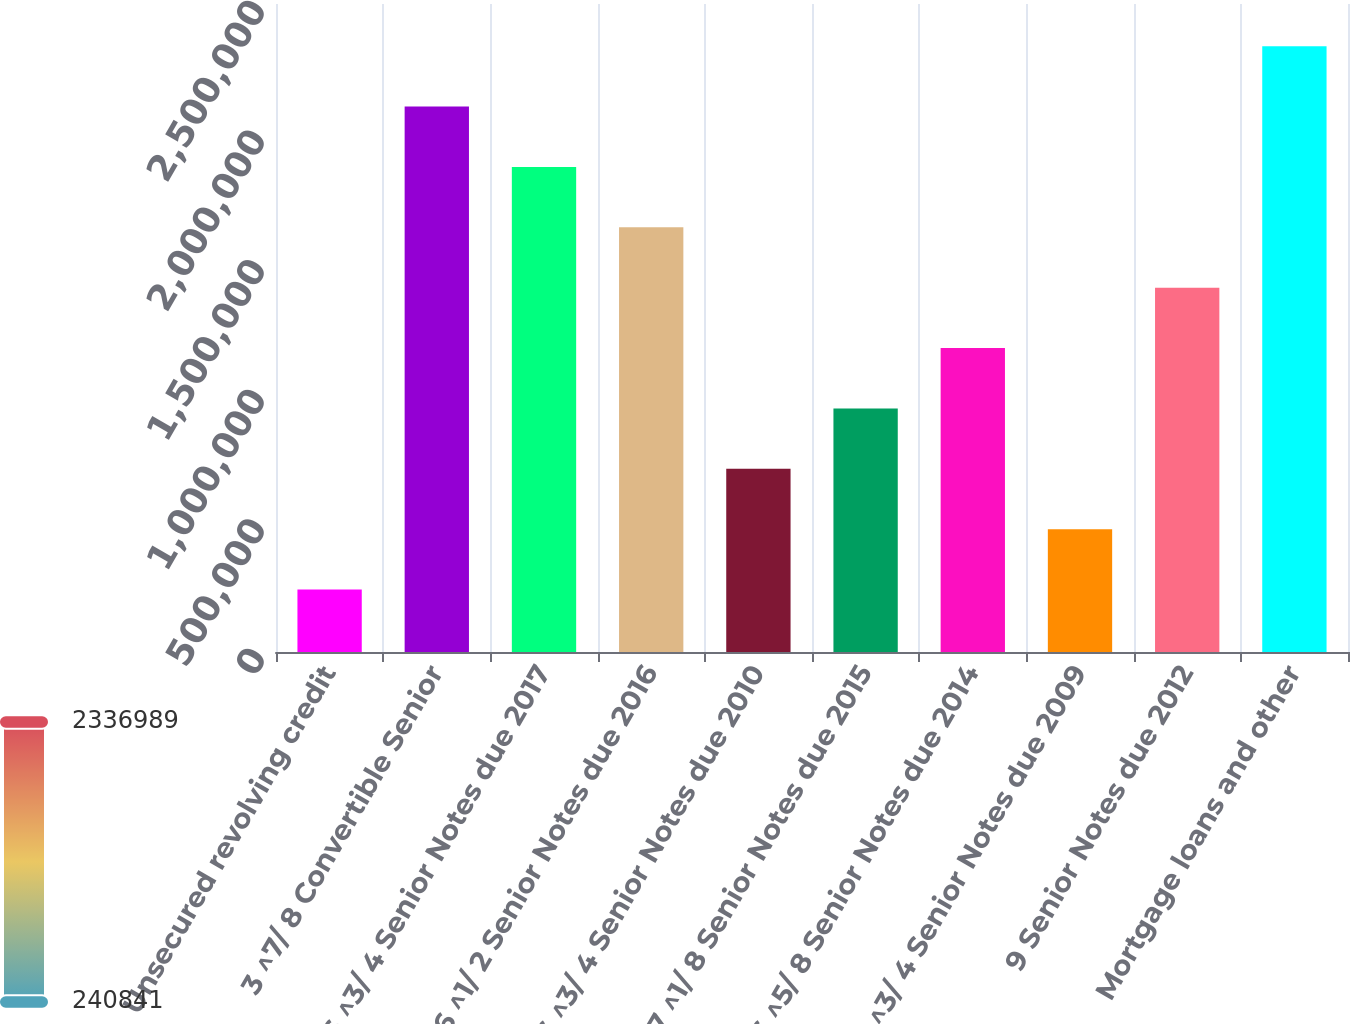<chart> <loc_0><loc_0><loc_500><loc_500><bar_chart><fcel>Unsecured revolving credit<fcel>3 ^7/ 8 Convertible Senior<fcel>6 ^3/ 4 Senior Notes due 2017<fcel>6 ^1/ 2 Senior Notes due 2016<fcel>6 ^3/ 4 Senior Notes due 2010<fcel>7 ^1/ 8 Senior Notes due 2015<fcel>6 ^5/ 8 Senior Notes due 2014<fcel>8 ^3/ 4 Senior Notes due 2009<fcel>9 Senior Notes due 2012<fcel>Mortgage loans and other<nl><fcel>240841<fcel>2.10408e+06<fcel>1.87118e+06<fcel>1.63827e+06<fcel>706652<fcel>939557<fcel>1.17246e+06<fcel>473747<fcel>1.40537e+06<fcel>2.33699e+06<nl></chart> 